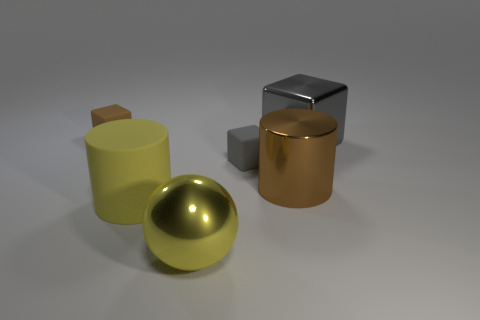Add 3 shiny blocks. How many objects exist? 9 Subtract all cylinders. How many objects are left? 4 Subtract all cylinders. Subtract all big cubes. How many objects are left? 3 Add 4 matte blocks. How many matte blocks are left? 6 Add 3 big objects. How many big objects exist? 7 Subtract 1 gray cubes. How many objects are left? 5 